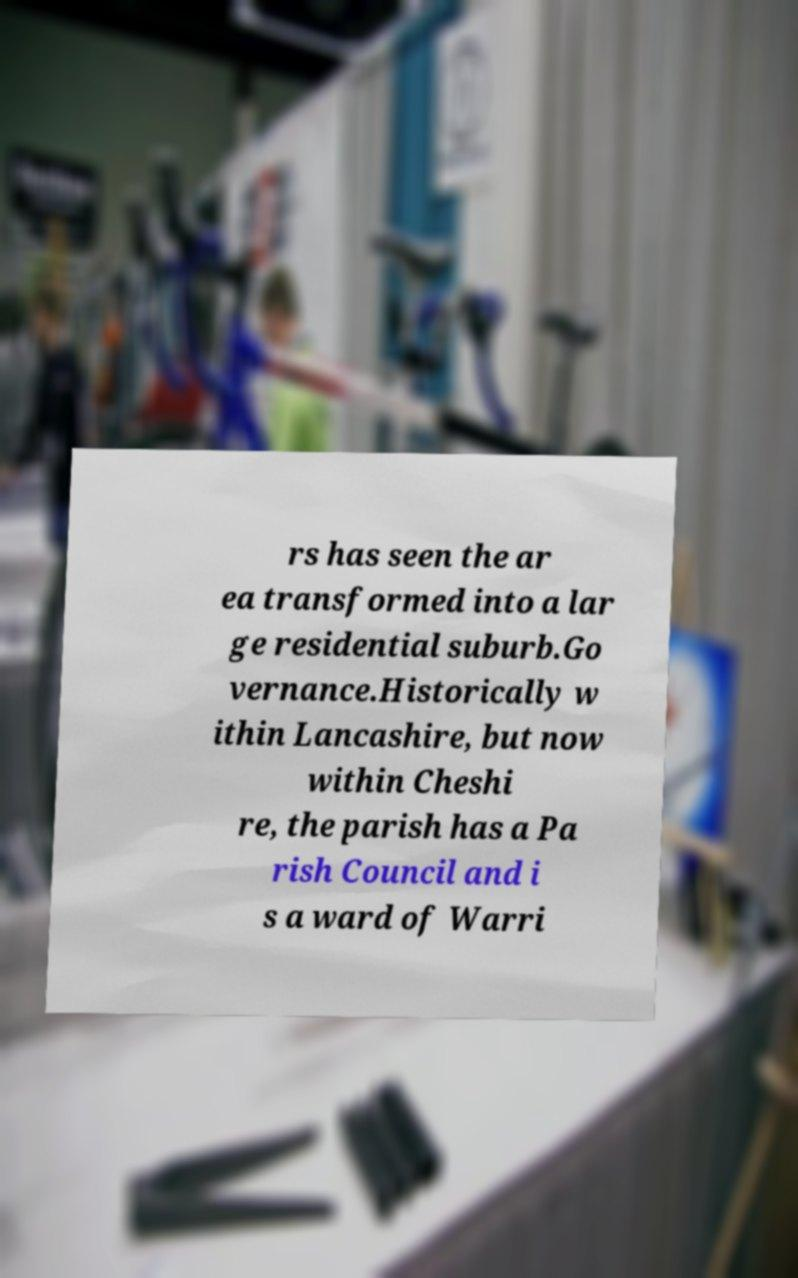Please identify and transcribe the text found in this image. rs has seen the ar ea transformed into a lar ge residential suburb.Go vernance.Historically w ithin Lancashire, but now within Cheshi re, the parish has a Pa rish Council and i s a ward of Warri 